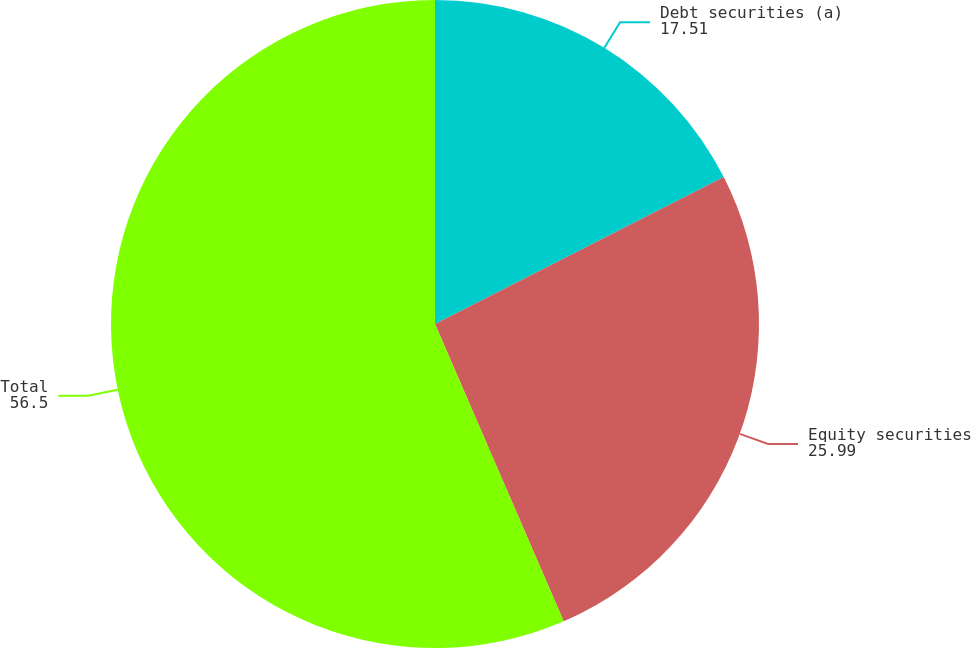Convert chart to OTSL. <chart><loc_0><loc_0><loc_500><loc_500><pie_chart><fcel>Debt securities (a)<fcel>Equity securities<fcel>Total<nl><fcel>17.51%<fcel>25.99%<fcel>56.5%<nl></chart> 